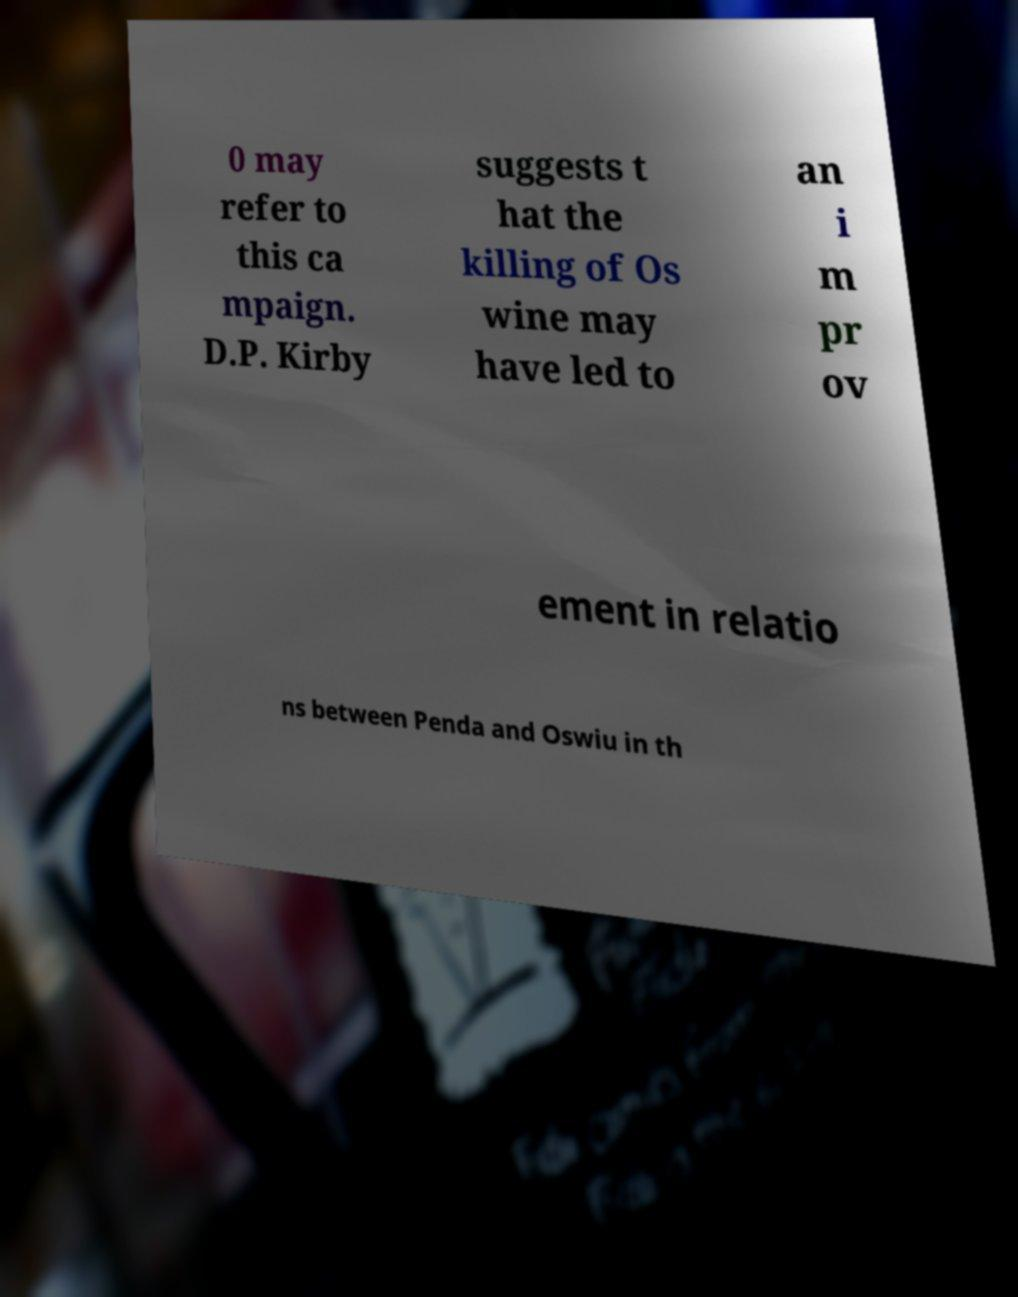Can you accurately transcribe the text from the provided image for me? 0 may refer to this ca mpaign. D.P. Kirby suggests t hat the killing of Os wine may have led to an i m pr ov ement in relatio ns between Penda and Oswiu in th 